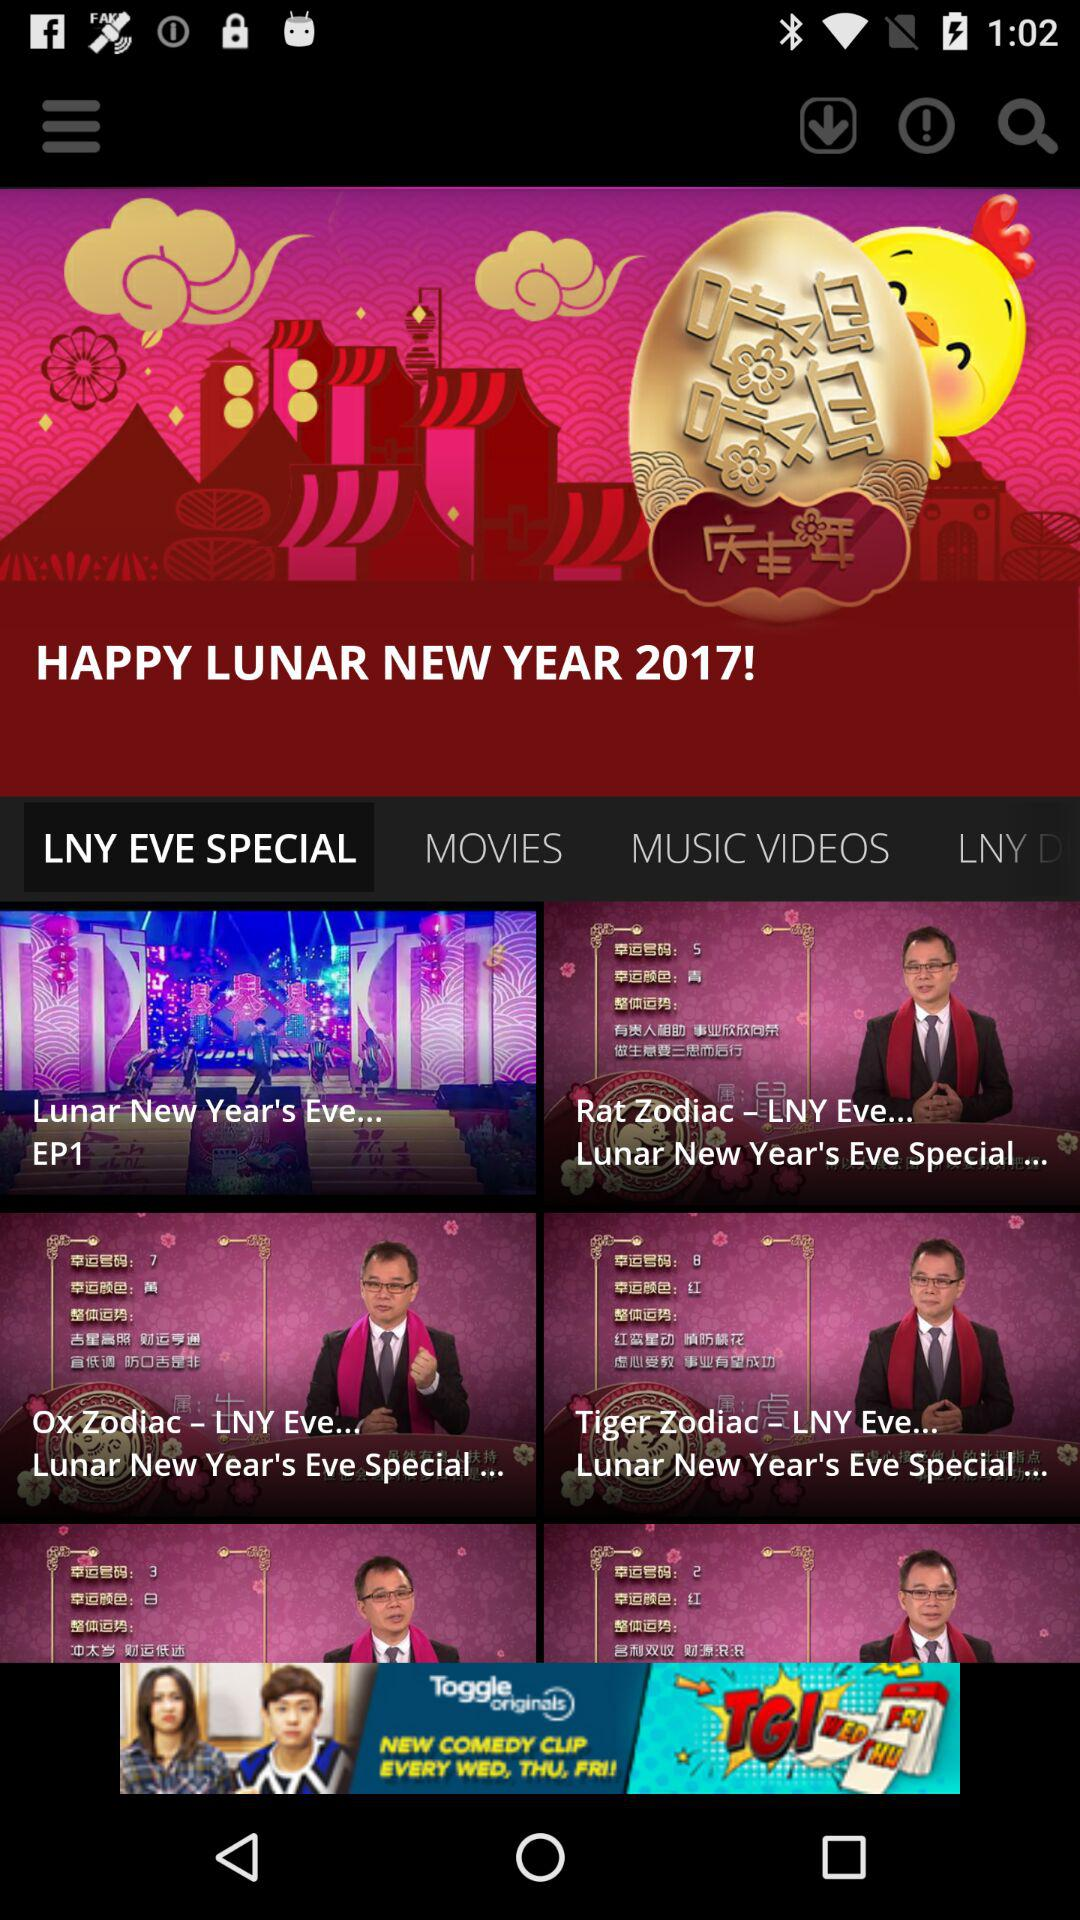What is the name of episode 1? The name of episode 1 is "Lunar New Year's Eve...". 